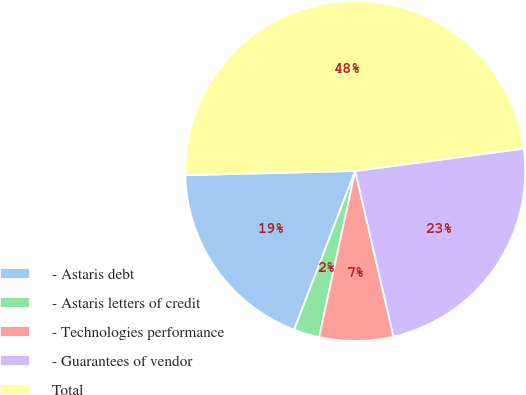<chart> <loc_0><loc_0><loc_500><loc_500><pie_chart><fcel>- Astaris debt<fcel>- Astaris letters of credit<fcel>- Technologies performance<fcel>- Guarantees of vendor<fcel>Total<nl><fcel>18.76%<fcel>2.44%<fcel>7.02%<fcel>23.48%<fcel>48.29%<nl></chart> 